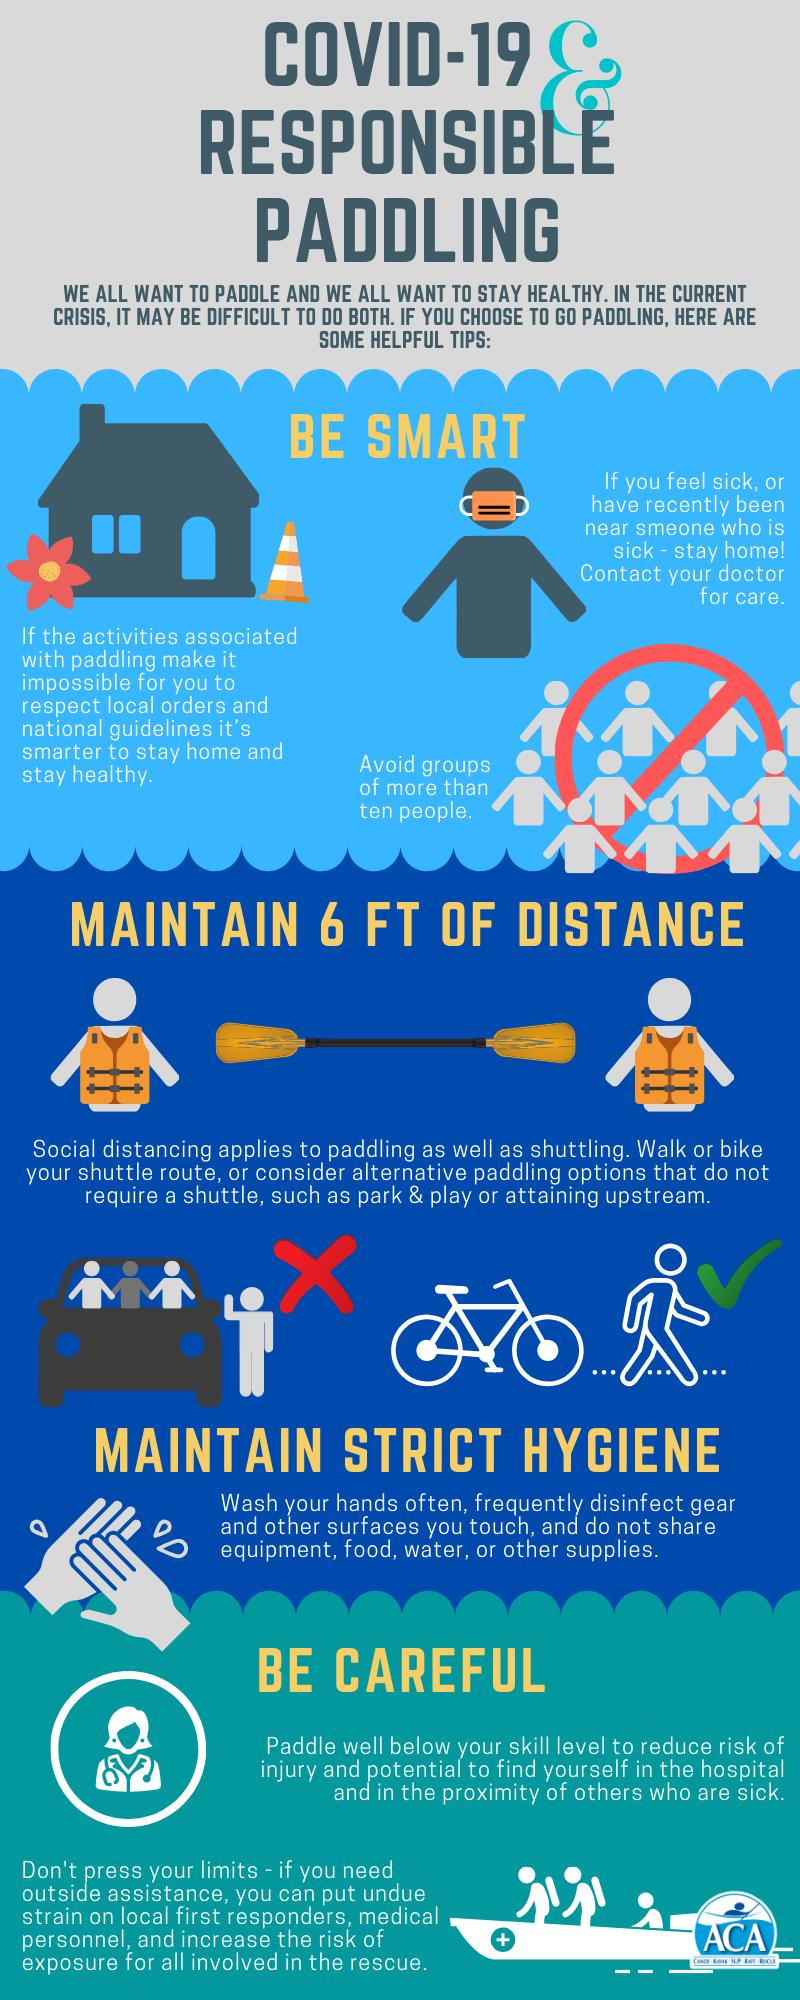Outline some significant characteristics in this image. Walking and biking are superior modes of transportation compared to shuttling. If you have been in the proximity of a sick person, it is essential to stay home to prevent the spread of illness. The maximum number of people that should be in a group is ten. 